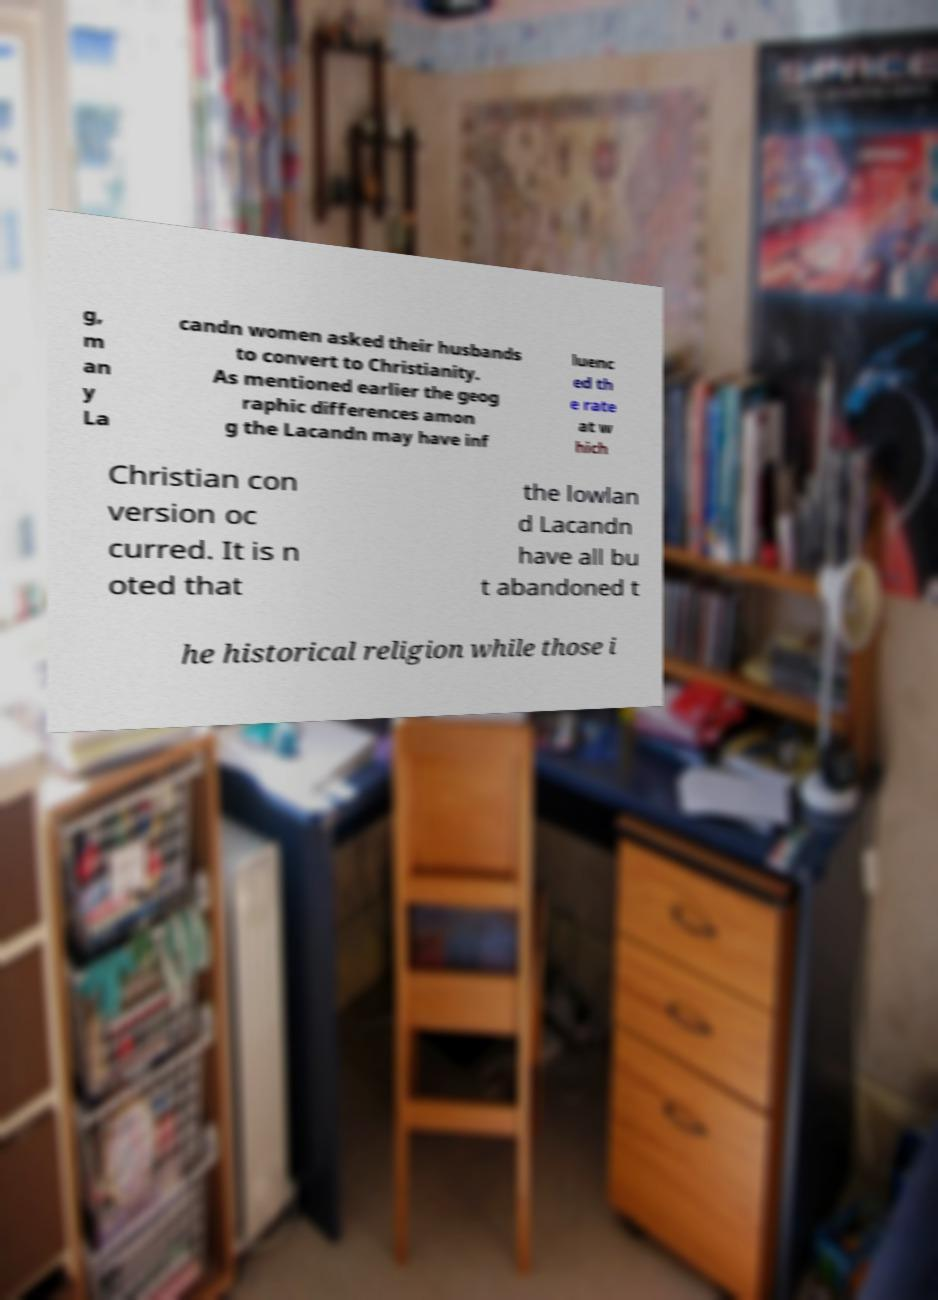Could you assist in decoding the text presented in this image and type it out clearly? g, m an y La candn women asked their husbands to convert to Christianity. As mentioned earlier the geog raphic differences amon g the Lacandn may have inf luenc ed th e rate at w hich Christian con version oc curred. It is n oted that the lowlan d Lacandn have all bu t abandoned t he historical religion while those i 